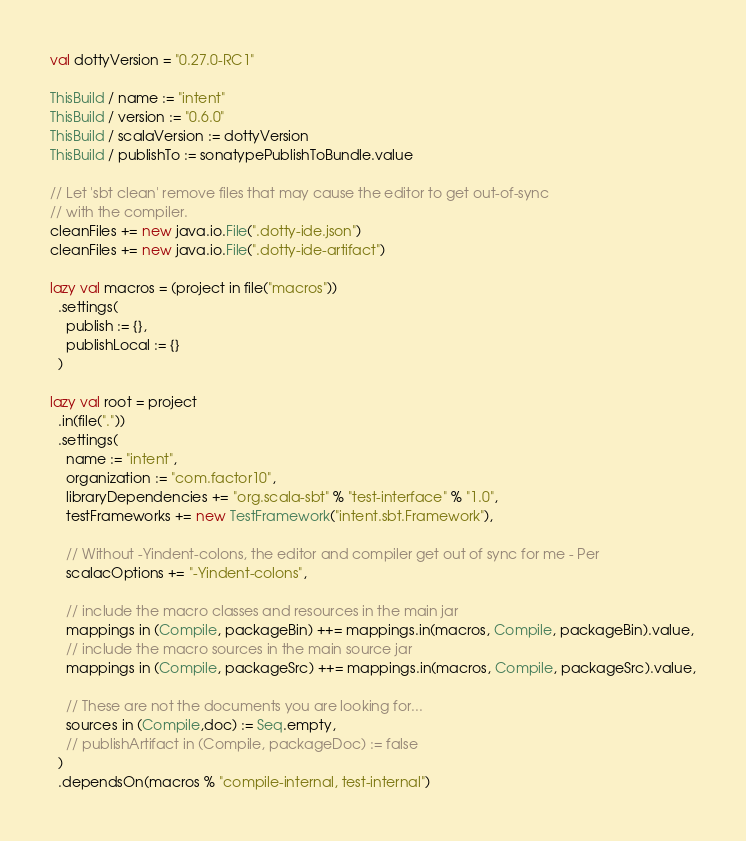Convert code to text. <code><loc_0><loc_0><loc_500><loc_500><_Scala_>val dottyVersion = "0.27.0-RC1"

ThisBuild / name := "intent"
ThisBuild / version := "0.6.0"
ThisBuild / scalaVersion := dottyVersion
ThisBuild / publishTo := sonatypePublishToBundle.value

// Let 'sbt clean' remove files that may cause the editor to get out-of-sync
// with the compiler.
cleanFiles += new java.io.File(".dotty-ide.json")
cleanFiles += new java.io.File(".dotty-ide-artifact")

lazy val macros = (project in file("macros"))
  .settings(
    publish := {},
    publishLocal := {}
  )

lazy val root = project
  .in(file("."))
  .settings(
    name := "intent",
    organization := "com.factor10",
    libraryDependencies += "org.scala-sbt" % "test-interface" % "1.0",
    testFrameworks += new TestFramework("intent.sbt.Framework"),

    // Without -Yindent-colons, the editor and compiler get out of sync for me - Per
    scalacOptions += "-Yindent-colons",

    // include the macro classes and resources in the main jar
    mappings in (Compile, packageBin) ++= mappings.in(macros, Compile, packageBin).value,
    // include the macro sources in the main source jar
    mappings in (Compile, packageSrc) ++= mappings.in(macros, Compile, packageSrc).value,

    // These are not the documents you are looking for...
    sources in (Compile,doc) := Seq.empty,
    // publishArtifact in (Compile, packageDoc) := false
  )
  .dependsOn(macros % "compile-internal, test-internal")
</code> 